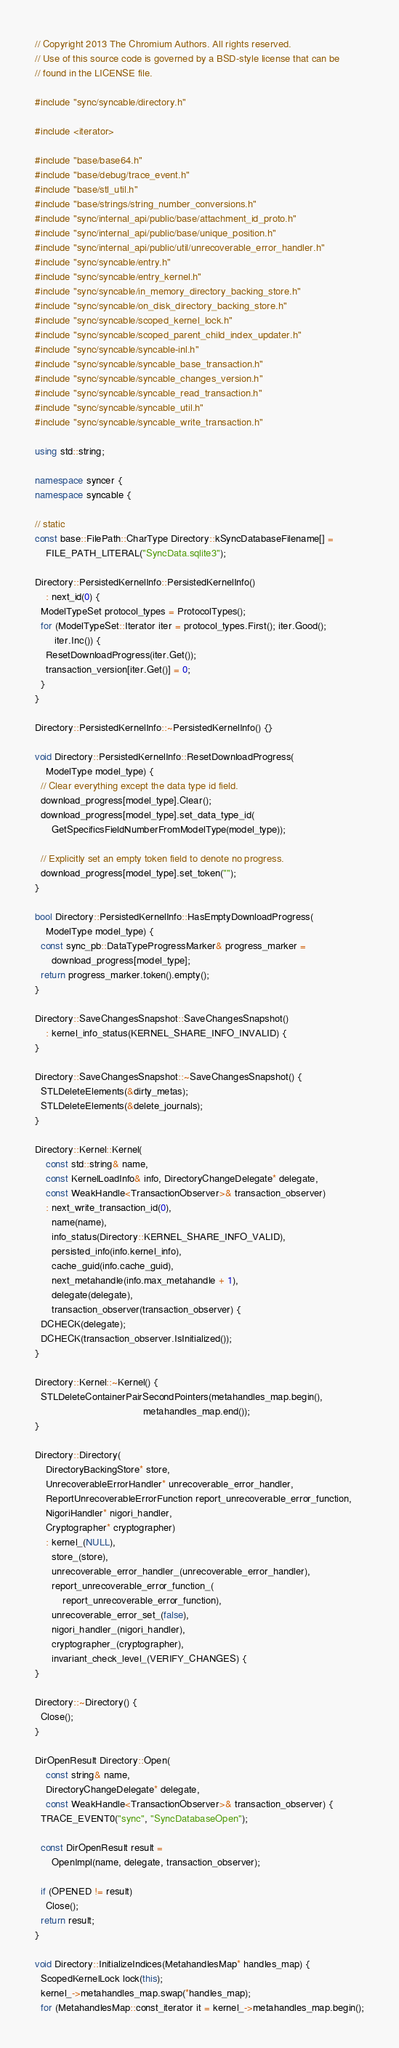Convert code to text. <code><loc_0><loc_0><loc_500><loc_500><_C++_>// Copyright 2013 The Chromium Authors. All rights reserved.
// Use of this source code is governed by a BSD-style license that can be
// found in the LICENSE file.

#include "sync/syncable/directory.h"

#include <iterator>

#include "base/base64.h"
#include "base/debug/trace_event.h"
#include "base/stl_util.h"
#include "base/strings/string_number_conversions.h"
#include "sync/internal_api/public/base/attachment_id_proto.h"
#include "sync/internal_api/public/base/unique_position.h"
#include "sync/internal_api/public/util/unrecoverable_error_handler.h"
#include "sync/syncable/entry.h"
#include "sync/syncable/entry_kernel.h"
#include "sync/syncable/in_memory_directory_backing_store.h"
#include "sync/syncable/on_disk_directory_backing_store.h"
#include "sync/syncable/scoped_kernel_lock.h"
#include "sync/syncable/scoped_parent_child_index_updater.h"
#include "sync/syncable/syncable-inl.h"
#include "sync/syncable/syncable_base_transaction.h"
#include "sync/syncable/syncable_changes_version.h"
#include "sync/syncable/syncable_read_transaction.h"
#include "sync/syncable/syncable_util.h"
#include "sync/syncable/syncable_write_transaction.h"

using std::string;

namespace syncer {
namespace syncable {

// static
const base::FilePath::CharType Directory::kSyncDatabaseFilename[] =
    FILE_PATH_LITERAL("SyncData.sqlite3");

Directory::PersistedKernelInfo::PersistedKernelInfo()
    : next_id(0) {
  ModelTypeSet protocol_types = ProtocolTypes();
  for (ModelTypeSet::Iterator iter = protocol_types.First(); iter.Good();
       iter.Inc()) {
    ResetDownloadProgress(iter.Get());
    transaction_version[iter.Get()] = 0;
  }
}

Directory::PersistedKernelInfo::~PersistedKernelInfo() {}

void Directory::PersistedKernelInfo::ResetDownloadProgress(
    ModelType model_type) {
  // Clear everything except the data type id field.
  download_progress[model_type].Clear();
  download_progress[model_type].set_data_type_id(
      GetSpecificsFieldNumberFromModelType(model_type));

  // Explicitly set an empty token field to denote no progress.
  download_progress[model_type].set_token("");
}

bool Directory::PersistedKernelInfo::HasEmptyDownloadProgress(
    ModelType model_type) {
  const sync_pb::DataTypeProgressMarker& progress_marker =
      download_progress[model_type];
  return progress_marker.token().empty();
}

Directory::SaveChangesSnapshot::SaveChangesSnapshot()
    : kernel_info_status(KERNEL_SHARE_INFO_INVALID) {
}

Directory::SaveChangesSnapshot::~SaveChangesSnapshot() {
  STLDeleteElements(&dirty_metas);
  STLDeleteElements(&delete_journals);
}

Directory::Kernel::Kernel(
    const std::string& name,
    const KernelLoadInfo& info, DirectoryChangeDelegate* delegate,
    const WeakHandle<TransactionObserver>& transaction_observer)
    : next_write_transaction_id(0),
      name(name),
      info_status(Directory::KERNEL_SHARE_INFO_VALID),
      persisted_info(info.kernel_info),
      cache_guid(info.cache_guid),
      next_metahandle(info.max_metahandle + 1),
      delegate(delegate),
      transaction_observer(transaction_observer) {
  DCHECK(delegate);
  DCHECK(transaction_observer.IsInitialized());
}

Directory::Kernel::~Kernel() {
  STLDeleteContainerPairSecondPointers(metahandles_map.begin(),
                                       metahandles_map.end());
}

Directory::Directory(
    DirectoryBackingStore* store,
    UnrecoverableErrorHandler* unrecoverable_error_handler,
    ReportUnrecoverableErrorFunction report_unrecoverable_error_function,
    NigoriHandler* nigori_handler,
    Cryptographer* cryptographer)
    : kernel_(NULL),
      store_(store),
      unrecoverable_error_handler_(unrecoverable_error_handler),
      report_unrecoverable_error_function_(
          report_unrecoverable_error_function),
      unrecoverable_error_set_(false),
      nigori_handler_(nigori_handler),
      cryptographer_(cryptographer),
      invariant_check_level_(VERIFY_CHANGES) {
}

Directory::~Directory() {
  Close();
}

DirOpenResult Directory::Open(
    const string& name,
    DirectoryChangeDelegate* delegate,
    const WeakHandle<TransactionObserver>& transaction_observer) {
  TRACE_EVENT0("sync", "SyncDatabaseOpen");

  const DirOpenResult result =
      OpenImpl(name, delegate, transaction_observer);

  if (OPENED != result)
    Close();
  return result;
}

void Directory::InitializeIndices(MetahandlesMap* handles_map) {
  ScopedKernelLock lock(this);
  kernel_->metahandles_map.swap(*handles_map);
  for (MetahandlesMap::const_iterator it = kernel_->metahandles_map.begin();</code> 